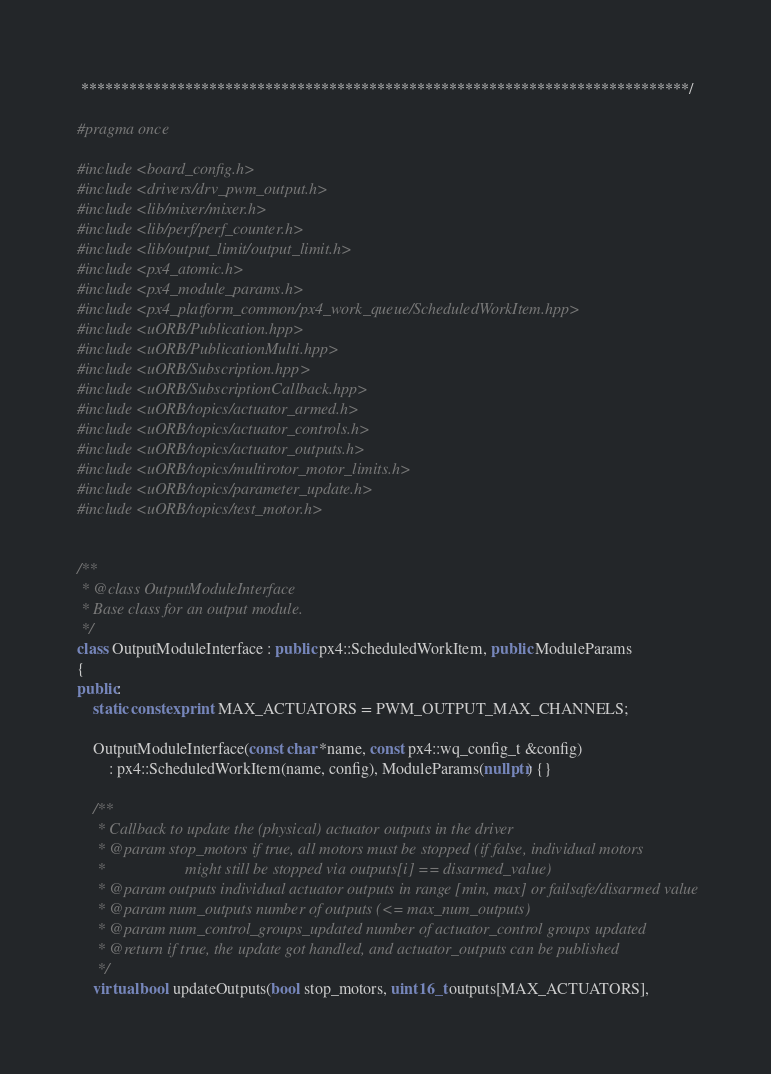Convert code to text. <code><loc_0><loc_0><loc_500><loc_500><_C++_> ****************************************************************************/

#pragma once

#include <board_config.h>
#include <drivers/drv_pwm_output.h>
#include <lib/mixer/mixer.h>
#include <lib/perf/perf_counter.h>
#include <lib/output_limit/output_limit.h>
#include <px4_atomic.h>
#include <px4_module_params.h>
#include <px4_platform_common/px4_work_queue/ScheduledWorkItem.hpp>
#include <uORB/Publication.hpp>
#include <uORB/PublicationMulti.hpp>
#include <uORB/Subscription.hpp>
#include <uORB/SubscriptionCallback.hpp>
#include <uORB/topics/actuator_armed.h>
#include <uORB/topics/actuator_controls.h>
#include <uORB/topics/actuator_outputs.h>
#include <uORB/topics/multirotor_motor_limits.h>
#include <uORB/topics/parameter_update.h>
#include <uORB/topics/test_motor.h>


/**
 * @class OutputModuleInterface
 * Base class for an output module.
 */
class OutputModuleInterface : public px4::ScheduledWorkItem, public ModuleParams
{
public:
	static constexpr int MAX_ACTUATORS = PWM_OUTPUT_MAX_CHANNELS;

	OutputModuleInterface(const char *name, const px4::wq_config_t &config)
		: px4::ScheduledWorkItem(name, config), ModuleParams(nullptr) {}

	/**
	 * Callback to update the (physical) actuator outputs in the driver
	 * @param stop_motors if true, all motors must be stopped (if false, individual motors
	 *                    might still be stopped via outputs[i] == disarmed_value)
	 * @param outputs individual actuator outputs in range [min, max] or failsafe/disarmed value
	 * @param num_outputs number of outputs (<= max_num_outputs)
	 * @param num_control_groups_updated number of actuator_control groups updated
	 * @return if true, the update got handled, and actuator_outputs can be published
	 */
	virtual bool updateOutputs(bool stop_motors, uint16_t outputs[MAX_ACTUATORS],</code> 